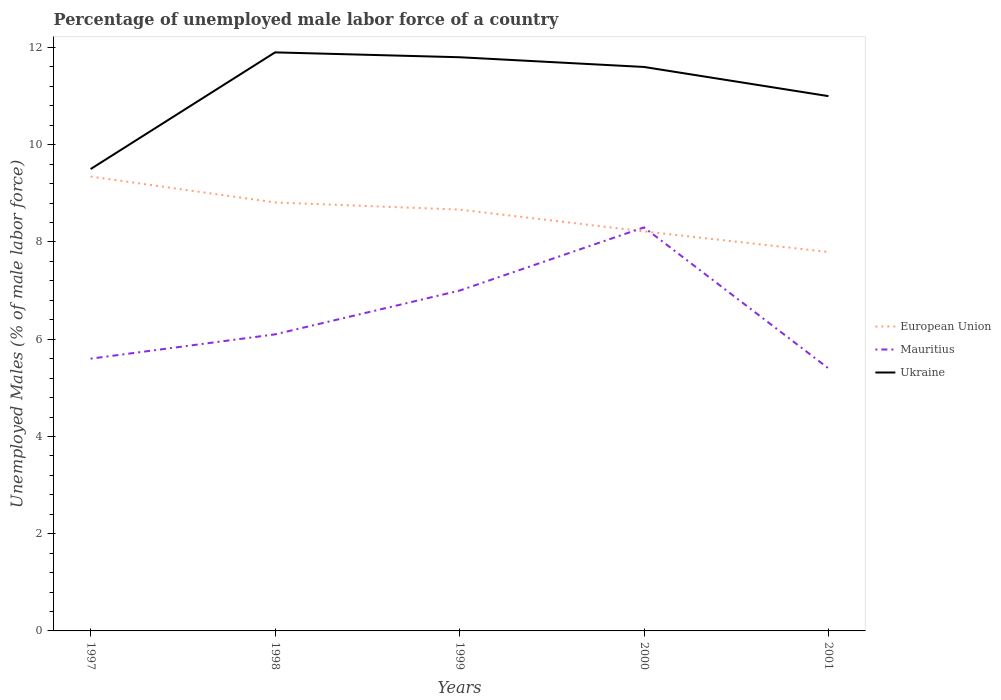How many different coloured lines are there?
Your answer should be compact. 3. Does the line corresponding to European Union intersect with the line corresponding to Ukraine?
Give a very brief answer. No. Is the number of lines equal to the number of legend labels?
Your answer should be compact. Yes. Across all years, what is the maximum percentage of unemployed male labor force in Mauritius?
Provide a short and direct response. 5.4. What is the total percentage of unemployed male labor force in Mauritius in the graph?
Give a very brief answer. 1.6. What is the difference between the highest and the second highest percentage of unemployed male labor force in Mauritius?
Provide a succinct answer. 2.9. What is the difference between the highest and the lowest percentage of unemployed male labor force in Ukraine?
Give a very brief answer. 3. What is the difference between two consecutive major ticks on the Y-axis?
Offer a very short reply. 2. Are the values on the major ticks of Y-axis written in scientific E-notation?
Your response must be concise. No. How are the legend labels stacked?
Your answer should be very brief. Vertical. What is the title of the graph?
Offer a terse response. Percentage of unemployed male labor force of a country. Does "Albania" appear as one of the legend labels in the graph?
Your answer should be compact. No. What is the label or title of the Y-axis?
Ensure brevity in your answer.  Unemployed Males (% of male labor force). What is the Unemployed Males (% of male labor force) of European Union in 1997?
Your response must be concise. 9.35. What is the Unemployed Males (% of male labor force) in Mauritius in 1997?
Your answer should be very brief. 5.6. What is the Unemployed Males (% of male labor force) of Ukraine in 1997?
Provide a succinct answer. 9.5. What is the Unemployed Males (% of male labor force) of European Union in 1998?
Your response must be concise. 8.81. What is the Unemployed Males (% of male labor force) in Mauritius in 1998?
Offer a terse response. 6.1. What is the Unemployed Males (% of male labor force) of Ukraine in 1998?
Provide a succinct answer. 11.9. What is the Unemployed Males (% of male labor force) of European Union in 1999?
Offer a very short reply. 8.67. What is the Unemployed Males (% of male labor force) in Mauritius in 1999?
Your answer should be very brief. 7. What is the Unemployed Males (% of male labor force) in Ukraine in 1999?
Ensure brevity in your answer.  11.8. What is the Unemployed Males (% of male labor force) of European Union in 2000?
Make the answer very short. 8.22. What is the Unemployed Males (% of male labor force) of Mauritius in 2000?
Give a very brief answer. 8.3. What is the Unemployed Males (% of male labor force) of Ukraine in 2000?
Offer a terse response. 11.6. What is the Unemployed Males (% of male labor force) in European Union in 2001?
Keep it short and to the point. 7.79. What is the Unemployed Males (% of male labor force) in Mauritius in 2001?
Offer a terse response. 5.4. Across all years, what is the maximum Unemployed Males (% of male labor force) in European Union?
Ensure brevity in your answer.  9.35. Across all years, what is the maximum Unemployed Males (% of male labor force) of Mauritius?
Give a very brief answer. 8.3. Across all years, what is the maximum Unemployed Males (% of male labor force) of Ukraine?
Your answer should be very brief. 11.9. Across all years, what is the minimum Unemployed Males (% of male labor force) in European Union?
Offer a very short reply. 7.79. Across all years, what is the minimum Unemployed Males (% of male labor force) in Mauritius?
Make the answer very short. 5.4. Across all years, what is the minimum Unemployed Males (% of male labor force) in Ukraine?
Your answer should be compact. 9.5. What is the total Unemployed Males (% of male labor force) of European Union in the graph?
Provide a short and direct response. 42.84. What is the total Unemployed Males (% of male labor force) of Mauritius in the graph?
Provide a succinct answer. 32.4. What is the total Unemployed Males (% of male labor force) in Ukraine in the graph?
Your answer should be very brief. 55.8. What is the difference between the Unemployed Males (% of male labor force) of European Union in 1997 and that in 1998?
Keep it short and to the point. 0.53. What is the difference between the Unemployed Males (% of male labor force) in Ukraine in 1997 and that in 1998?
Provide a short and direct response. -2.4. What is the difference between the Unemployed Males (% of male labor force) of European Union in 1997 and that in 1999?
Provide a succinct answer. 0.68. What is the difference between the Unemployed Males (% of male labor force) in Mauritius in 1997 and that in 1999?
Make the answer very short. -1.4. What is the difference between the Unemployed Males (% of male labor force) in Ukraine in 1997 and that in 1999?
Make the answer very short. -2.3. What is the difference between the Unemployed Males (% of male labor force) in European Union in 1997 and that in 2000?
Your answer should be compact. 1.13. What is the difference between the Unemployed Males (% of male labor force) of European Union in 1997 and that in 2001?
Ensure brevity in your answer.  1.55. What is the difference between the Unemployed Males (% of male labor force) in Mauritius in 1997 and that in 2001?
Keep it short and to the point. 0.2. What is the difference between the Unemployed Males (% of male labor force) of European Union in 1998 and that in 1999?
Offer a very short reply. 0.15. What is the difference between the Unemployed Males (% of male labor force) of European Union in 1998 and that in 2000?
Your response must be concise. 0.59. What is the difference between the Unemployed Males (% of male labor force) in Mauritius in 1998 and that in 2000?
Make the answer very short. -2.2. What is the difference between the Unemployed Males (% of male labor force) in Ukraine in 1998 and that in 2000?
Your response must be concise. 0.3. What is the difference between the Unemployed Males (% of male labor force) in European Union in 1998 and that in 2001?
Your response must be concise. 1.02. What is the difference between the Unemployed Males (% of male labor force) in Ukraine in 1998 and that in 2001?
Ensure brevity in your answer.  0.9. What is the difference between the Unemployed Males (% of male labor force) in European Union in 1999 and that in 2000?
Ensure brevity in your answer.  0.45. What is the difference between the Unemployed Males (% of male labor force) in Mauritius in 1999 and that in 2000?
Ensure brevity in your answer.  -1.3. What is the difference between the Unemployed Males (% of male labor force) of Ukraine in 1999 and that in 2000?
Offer a terse response. 0.2. What is the difference between the Unemployed Males (% of male labor force) of European Union in 1999 and that in 2001?
Make the answer very short. 0.87. What is the difference between the Unemployed Males (% of male labor force) in European Union in 2000 and that in 2001?
Provide a succinct answer. 0.42. What is the difference between the Unemployed Males (% of male labor force) of Mauritius in 2000 and that in 2001?
Your answer should be very brief. 2.9. What is the difference between the Unemployed Males (% of male labor force) in Ukraine in 2000 and that in 2001?
Offer a very short reply. 0.6. What is the difference between the Unemployed Males (% of male labor force) of European Union in 1997 and the Unemployed Males (% of male labor force) of Mauritius in 1998?
Make the answer very short. 3.25. What is the difference between the Unemployed Males (% of male labor force) of European Union in 1997 and the Unemployed Males (% of male labor force) of Ukraine in 1998?
Your response must be concise. -2.55. What is the difference between the Unemployed Males (% of male labor force) in European Union in 1997 and the Unemployed Males (% of male labor force) in Mauritius in 1999?
Your response must be concise. 2.35. What is the difference between the Unemployed Males (% of male labor force) of European Union in 1997 and the Unemployed Males (% of male labor force) of Ukraine in 1999?
Provide a succinct answer. -2.45. What is the difference between the Unemployed Males (% of male labor force) of Mauritius in 1997 and the Unemployed Males (% of male labor force) of Ukraine in 1999?
Offer a terse response. -6.2. What is the difference between the Unemployed Males (% of male labor force) of European Union in 1997 and the Unemployed Males (% of male labor force) of Mauritius in 2000?
Your response must be concise. 1.05. What is the difference between the Unemployed Males (% of male labor force) in European Union in 1997 and the Unemployed Males (% of male labor force) in Ukraine in 2000?
Your response must be concise. -2.25. What is the difference between the Unemployed Males (% of male labor force) of European Union in 1997 and the Unemployed Males (% of male labor force) of Mauritius in 2001?
Give a very brief answer. 3.95. What is the difference between the Unemployed Males (% of male labor force) in European Union in 1997 and the Unemployed Males (% of male labor force) in Ukraine in 2001?
Keep it short and to the point. -1.65. What is the difference between the Unemployed Males (% of male labor force) of Mauritius in 1997 and the Unemployed Males (% of male labor force) of Ukraine in 2001?
Provide a succinct answer. -5.4. What is the difference between the Unemployed Males (% of male labor force) in European Union in 1998 and the Unemployed Males (% of male labor force) in Mauritius in 1999?
Make the answer very short. 1.81. What is the difference between the Unemployed Males (% of male labor force) in European Union in 1998 and the Unemployed Males (% of male labor force) in Ukraine in 1999?
Your response must be concise. -2.99. What is the difference between the Unemployed Males (% of male labor force) of Mauritius in 1998 and the Unemployed Males (% of male labor force) of Ukraine in 1999?
Offer a very short reply. -5.7. What is the difference between the Unemployed Males (% of male labor force) of European Union in 1998 and the Unemployed Males (% of male labor force) of Mauritius in 2000?
Make the answer very short. 0.51. What is the difference between the Unemployed Males (% of male labor force) of European Union in 1998 and the Unemployed Males (% of male labor force) of Ukraine in 2000?
Provide a short and direct response. -2.79. What is the difference between the Unemployed Males (% of male labor force) of European Union in 1998 and the Unemployed Males (% of male labor force) of Mauritius in 2001?
Provide a short and direct response. 3.41. What is the difference between the Unemployed Males (% of male labor force) in European Union in 1998 and the Unemployed Males (% of male labor force) in Ukraine in 2001?
Provide a succinct answer. -2.19. What is the difference between the Unemployed Males (% of male labor force) of Mauritius in 1998 and the Unemployed Males (% of male labor force) of Ukraine in 2001?
Ensure brevity in your answer.  -4.9. What is the difference between the Unemployed Males (% of male labor force) of European Union in 1999 and the Unemployed Males (% of male labor force) of Mauritius in 2000?
Offer a very short reply. 0.37. What is the difference between the Unemployed Males (% of male labor force) in European Union in 1999 and the Unemployed Males (% of male labor force) in Ukraine in 2000?
Give a very brief answer. -2.93. What is the difference between the Unemployed Males (% of male labor force) of European Union in 1999 and the Unemployed Males (% of male labor force) of Mauritius in 2001?
Ensure brevity in your answer.  3.27. What is the difference between the Unemployed Males (% of male labor force) of European Union in 1999 and the Unemployed Males (% of male labor force) of Ukraine in 2001?
Offer a terse response. -2.33. What is the difference between the Unemployed Males (% of male labor force) of Mauritius in 1999 and the Unemployed Males (% of male labor force) of Ukraine in 2001?
Keep it short and to the point. -4. What is the difference between the Unemployed Males (% of male labor force) in European Union in 2000 and the Unemployed Males (% of male labor force) in Mauritius in 2001?
Offer a very short reply. 2.82. What is the difference between the Unemployed Males (% of male labor force) in European Union in 2000 and the Unemployed Males (% of male labor force) in Ukraine in 2001?
Your response must be concise. -2.78. What is the average Unemployed Males (% of male labor force) in European Union per year?
Your answer should be very brief. 8.57. What is the average Unemployed Males (% of male labor force) of Mauritius per year?
Offer a very short reply. 6.48. What is the average Unemployed Males (% of male labor force) of Ukraine per year?
Make the answer very short. 11.16. In the year 1997, what is the difference between the Unemployed Males (% of male labor force) of European Union and Unemployed Males (% of male labor force) of Mauritius?
Your answer should be very brief. 3.75. In the year 1997, what is the difference between the Unemployed Males (% of male labor force) in European Union and Unemployed Males (% of male labor force) in Ukraine?
Offer a terse response. -0.15. In the year 1998, what is the difference between the Unemployed Males (% of male labor force) of European Union and Unemployed Males (% of male labor force) of Mauritius?
Offer a very short reply. 2.71. In the year 1998, what is the difference between the Unemployed Males (% of male labor force) of European Union and Unemployed Males (% of male labor force) of Ukraine?
Give a very brief answer. -3.09. In the year 1998, what is the difference between the Unemployed Males (% of male labor force) of Mauritius and Unemployed Males (% of male labor force) of Ukraine?
Provide a short and direct response. -5.8. In the year 1999, what is the difference between the Unemployed Males (% of male labor force) in European Union and Unemployed Males (% of male labor force) in Mauritius?
Ensure brevity in your answer.  1.67. In the year 1999, what is the difference between the Unemployed Males (% of male labor force) of European Union and Unemployed Males (% of male labor force) of Ukraine?
Give a very brief answer. -3.13. In the year 2000, what is the difference between the Unemployed Males (% of male labor force) of European Union and Unemployed Males (% of male labor force) of Mauritius?
Your answer should be compact. -0.08. In the year 2000, what is the difference between the Unemployed Males (% of male labor force) in European Union and Unemployed Males (% of male labor force) in Ukraine?
Give a very brief answer. -3.38. In the year 2000, what is the difference between the Unemployed Males (% of male labor force) in Mauritius and Unemployed Males (% of male labor force) in Ukraine?
Give a very brief answer. -3.3. In the year 2001, what is the difference between the Unemployed Males (% of male labor force) in European Union and Unemployed Males (% of male labor force) in Mauritius?
Give a very brief answer. 2.39. In the year 2001, what is the difference between the Unemployed Males (% of male labor force) of European Union and Unemployed Males (% of male labor force) of Ukraine?
Ensure brevity in your answer.  -3.21. What is the ratio of the Unemployed Males (% of male labor force) in European Union in 1997 to that in 1998?
Provide a succinct answer. 1.06. What is the ratio of the Unemployed Males (% of male labor force) in Mauritius in 1997 to that in 1998?
Provide a short and direct response. 0.92. What is the ratio of the Unemployed Males (% of male labor force) in Ukraine in 1997 to that in 1998?
Provide a succinct answer. 0.8. What is the ratio of the Unemployed Males (% of male labor force) of European Union in 1997 to that in 1999?
Make the answer very short. 1.08. What is the ratio of the Unemployed Males (% of male labor force) of Mauritius in 1997 to that in 1999?
Give a very brief answer. 0.8. What is the ratio of the Unemployed Males (% of male labor force) of Ukraine in 1997 to that in 1999?
Offer a very short reply. 0.81. What is the ratio of the Unemployed Males (% of male labor force) in European Union in 1997 to that in 2000?
Provide a succinct answer. 1.14. What is the ratio of the Unemployed Males (% of male labor force) of Mauritius in 1997 to that in 2000?
Your answer should be compact. 0.67. What is the ratio of the Unemployed Males (% of male labor force) in Ukraine in 1997 to that in 2000?
Provide a short and direct response. 0.82. What is the ratio of the Unemployed Males (% of male labor force) in European Union in 1997 to that in 2001?
Offer a very short reply. 1.2. What is the ratio of the Unemployed Males (% of male labor force) in Ukraine in 1997 to that in 2001?
Keep it short and to the point. 0.86. What is the ratio of the Unemployed Males (% of male labor force) of European Union in 1998 to that in 1999?
Ensure brevity in your answer.  1.02. What is the ratio of the Unemployed Males (% of male labor force) of Mauritius in 1998 to that in 1999?
Ensure brevity in your answer.  0.87. What is the ratio of the Unemployed Males (% of male labor force) of Ukraine in 1998 to that in 1999?
Your answer should be compact. 1.01. What is the ratio of the Unemployed Males (% of male labor force) in European Union in 1998 to that in 2000?
Your response must be concise. 1.07. What is the ratio of the Unemployed Males (% of male labor force) in Mauritius in 1998 to that in 2000?
Provide a succinct answer. 0.73. What is the ratio of the Unemployed Males (% of male labor force) of Ukraine in 1998 to that in 2000?
Offer a very short reply. 1.03. What is the ratio of the Unemployed Males (% of male labor force) of European Union in 1998 to that in 2001?
Your answer should be compact. 1.13. What is the ratio of the Unemployed Males (% of male labor force) of Mauritius in 1998 to that in 2001?
Offer a terse response. 1.13. What is the ratio of the Unemployed Males (% of male labor force) of Ukraine in 1998 to that in 2001?
Keep it short and to the point. 1.08. What is the ratio of the Unemployed Males (% of male labor force) of European Union in 1999 to that in 2000?
Make the answer very short. 1.05. What is the ratio of the Unemployed Males (% of male labor force) of Mauritius in 1999 to that in 2000?
Offer a terse response. 0.84. What is the ratio of the Unemployed Males (% of male labor force) in Ukraine in 1999 to that in 2000?
Ensure brevity in your answer.  1.02. What is the ratio of the Unemployed Males (% of male labor force) of European Union in 1999 to that in 2001?
Ensure brevity in your answer.  1.11. What is the ratio of the Unemployed Males (% of male labor force) of Mauritius in 1999 to that in 2001?
Your response must be concise. 1.3. What is the ratio of the Unemployed Males (% of male labor force) in Ukraine in 1999 to that in 2001?
Ensure brevity in your answer.  1.07. What is the ratio of the Unemployed Males (% of male labor force) in European Union in 2000 to that in 2001?
Provide a short and direct response. 1.05. What is the ratio of the Unemployed Males (% of male labor force) in Mauritius in 2000 to that in 2001?
Provide a short and direct response. 1.54. What is the ratio of the Unemployed Males (% of male labor force) in Ukraine in 2000 to that in 2001?
Offer a very short reply. 1.05. What is the difference between the highest and the second highest Unemployed Males (% of male labor force) of European Union?
Your response must be concise. 0.53. What is the difference between the highest and the second highest Unemployed Males (% of male labor force) in Mauritius?
Your response must be concise. 1.3. What is the difference between the highest and the second highest Unemployed Males (% of male labor force) in Ukraine?
Offer a very short reply. 0.1. What is the difference between the highest and the lowest Unemployed Males (% of male labor force) in European Union?
Ensure brevity in your answer.  1.55. What is the difference between the highest and the lowest Unemployed Males (% of male labor force) in Mauritius?
Make the answer very short. 2.9. What is the difference between the highest and the lowest Unemployed Males (% of male labor force) of Ukraine?
Offer a terse response. 2.4. 